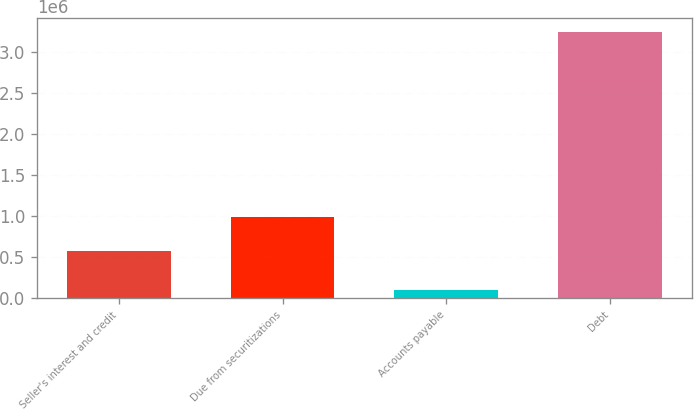Convert chart. <chart><loc_0><loc_0><loc_500><loc_500><bar_chart><fcel>Seller's interest and credit<fcel>Due from securitizations<fcel>Accounts payable<fcel>Debt<nl><fcel>574004<fcel>992523<fcel>103891<fcel>3.24735e+06<nl></chart> 